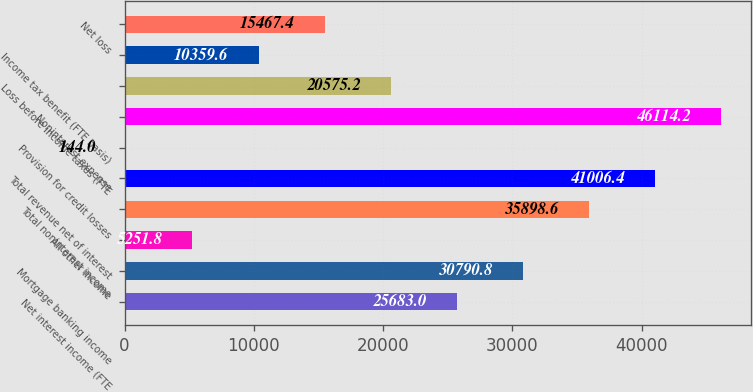Convert chart to OTSL. <chart><loc_0><loc_0><loc_500><loc_500><bar_chart><fcel>Net interest income (FTE<fcel>Mortgage banking income<fcel>All other income<fcel>Total noninterest income<fcel>Total revenue net of interest<fcel>Provision for credit losses<fcel>Noninterest expense<fcel>Loss before income taxes (FTE<fcel>Income tax benefit (FTE basis)<fcel>Net loss<nl><fcel>25683<fcel>30790.8<fcel>5251.8<fcel>35898.6<fcel>41006.4<fcel>144<fcel>46114.2<fcel>20575.2<fcel>10359.6<fcel>15467.4<nl></chart> 